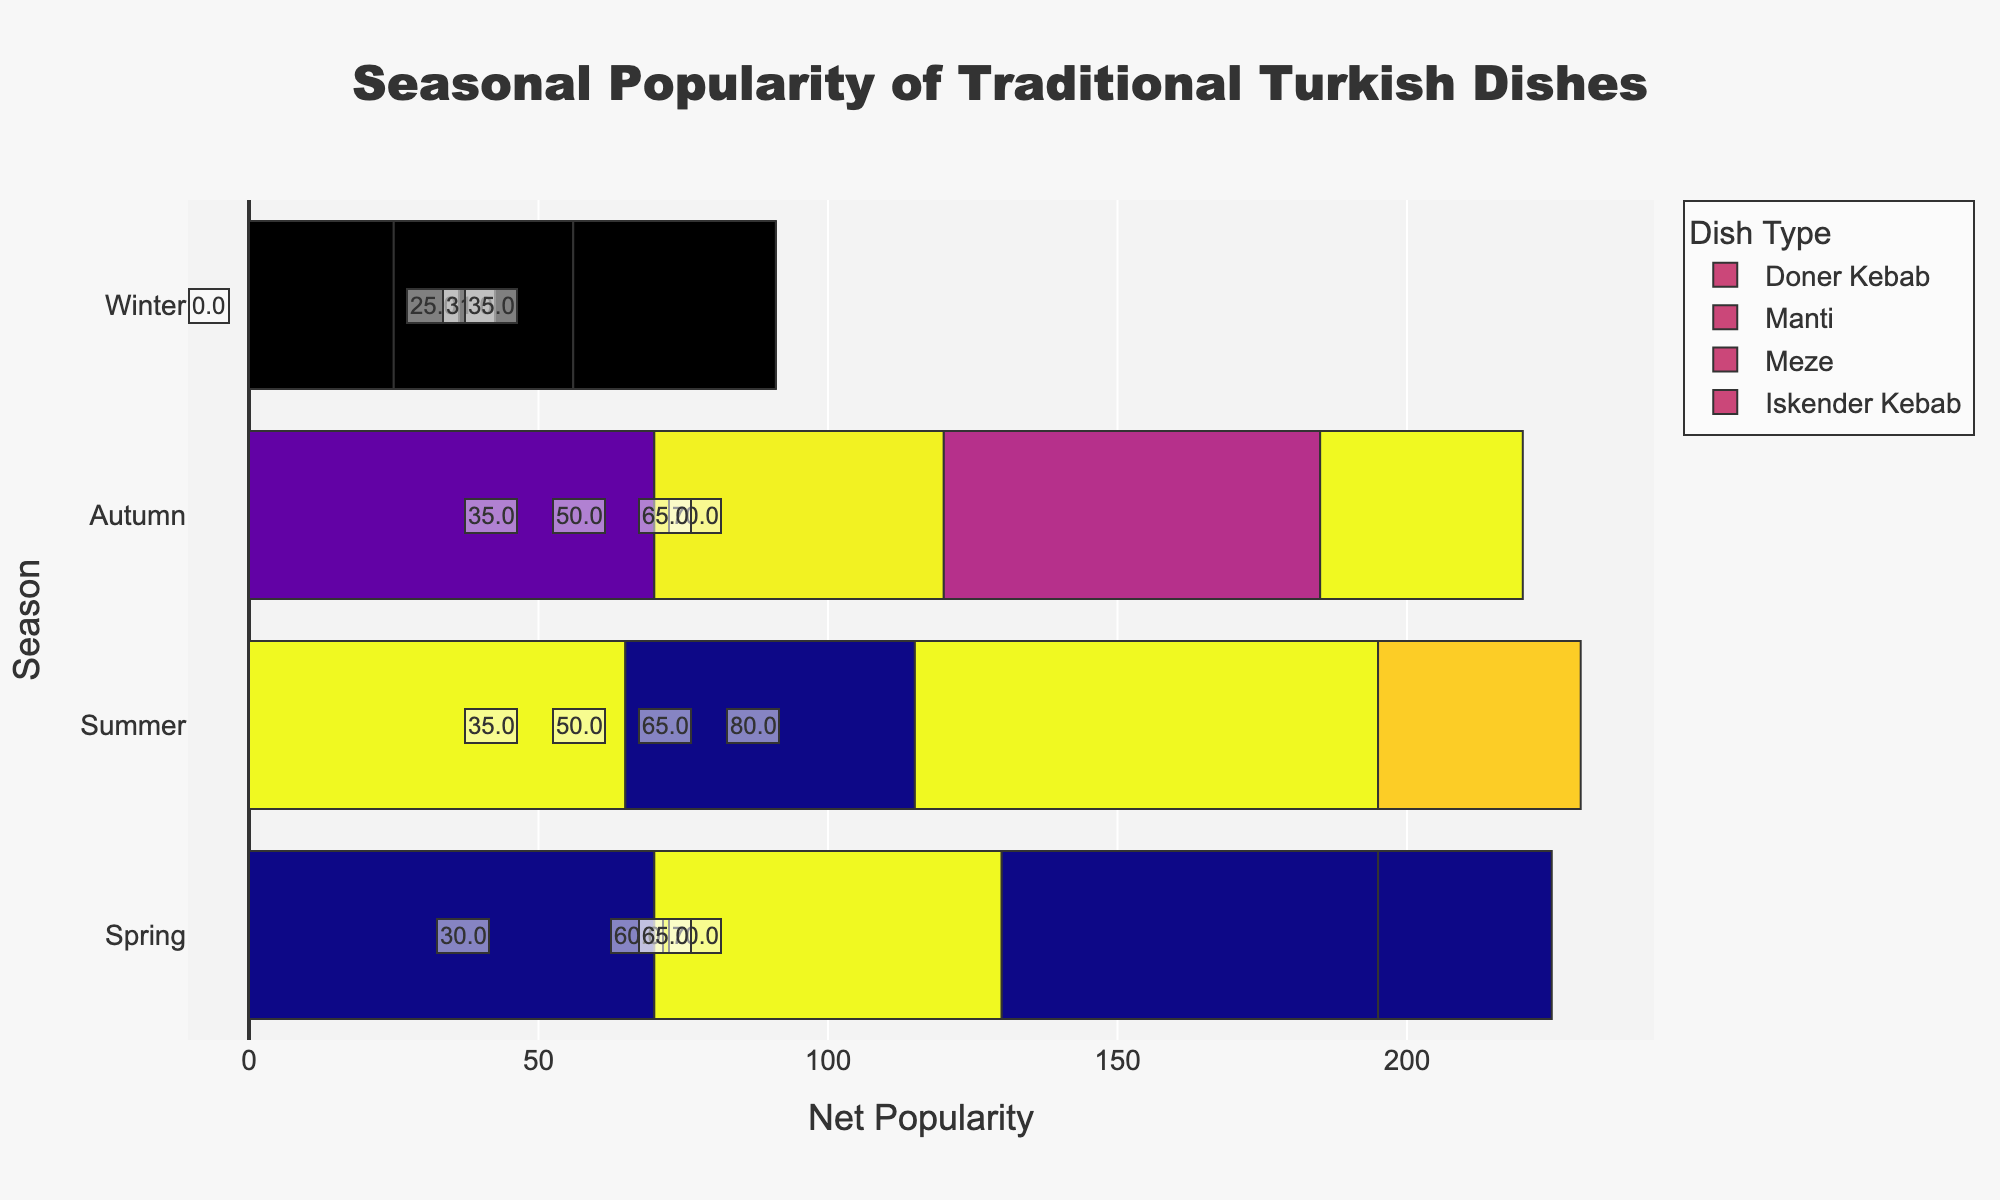What's the overall trend in the popularity of Doner Kebab across the seasons? To determine the trend in the popularity of Doner Kebab, observe the "Net Popularity" values for Doner Kebab over each season. Spring has 30-10=20, Summer has 40-10=30, Autumn has 35-10=25, Winter has 20-25=-5. We can see initially increasing from Spring to Summer, declining in Autumn, and further declining in Winter.
Answer: Decreasing Which dish shows the highest net popularity during the Summer? Identify the highest net popularity value in the Summer season by comparing the "Net Popularity" values of all dishes. Doner Kebab has 30, Manti has 20, Meze has 40, and Iskender Kebab has 5 for Summer.
Answer: Meze Which season has the lowest overall net popularity for Iskender Kebab? To find this, compare the "Net Popularity" for Iskender Kebab across all seasons. Spring (0), Summer (5), Autumn (0), Winter (-5). The lowest is in Winter.
Answer: Winter Compare the net popularity of Manti between Spring and Winter. Which season does it perform better? Calculate the net popularity for Manti in both Spring and Winter. Spring (25+45-7-3)=60, Winter (18+35-15-7)=31. Manti performs better in Spring.
Answer: Spring Which dish's popularity fluctuates the most across all seasons? Calculate the range (max-min) of net popularity for each dish across all seasons. Doner Kebab: 30-(-5)=35, Manti: 60-31=29, Meze: 45-40=5, Iskender Kebab: 5-(-5)=10. Doner Kebab has the largest range, indicating the most fluctuation.
Answer: Doner Kebab What are the overall popularity trends of Meze contrasted with Iskender Kebab? Compare the net popularity values for Meze and Iskender Kebab for each season. Meze: Spring (65), Summer (80), Autumn (70), Winter (65); Iskender Kebab: Spring (0), Summer (5), Autumn (0), Winter (-5). Meze maintains a consistently higher popularity with minor fluctuations, while Iskender Kebab has low popularity with negative values in Winter.
Answer: Meze is more stable and higher in popularity; Iskender Kebab is consistently low Calculate the total net popularity of all dishes in Autumn. Sum the net popularity values for all dishes in Autumn. Doner Kebab (20), Manti (20), Meze (65), Iskender Kebab (0). Total: 20+20+65+0=105.
Answer: 105 